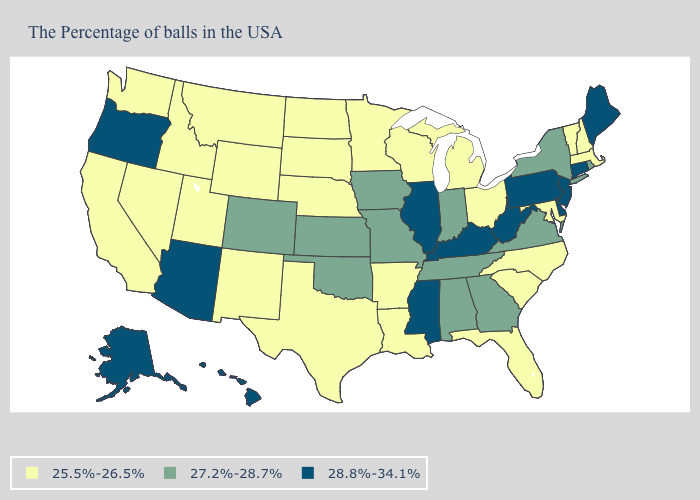What is the lowest value in the USA?
Be succinct. 25.5%-26.5%. Among the states that border South Dakota , does Nebraska have the highest value?
Answer briefly. No. Which states hav the highest value in the MidWest?
Quick response, please. Illinois. Which states have the highest value in the USA?
Keep it brief. Maine, Connecticut, New Jersey, Delaware, Pennsylvania, West Virginia, Kentucky, Illinois, Mississippi, Arizona, Oregon, Alaska, Hawaii. Is the legend a continuous bar?
Write a very short answer. No. What is the lowest value in the USA?
Write a very short answer. 25.5%-26.5%. Which states have the lowest value in the MidWest?
Concise answer only. Ohio, Michigan, Wisconsin, Minnesota, Nebraska, South Dakota, North Dakota. What is the lowest value in states that border Missouri?
Answer briefly. 25.5%-26.5%. Name the states that have a value in the range 28.8%-34.1%?
Concise answer only. Maine, Connecticut, New Jersey, Delaware, Pennsylvania, West Virginia, Kentucky, Illinois, Mississippi, Arizona, Oregon, Alaska, Hawaii. Name the states that have a value in the range 28.8%-34.1%?
Keep it brief. Maine, Connecticut, New Jersey, Delaware, Pennsylvania, West Virginia, Kentucky, Illinois, Mississippi, Arizona, Oregon, Alaska, Hawaii. Which states have the lowest value in the USA?
Keep it brief. Massachusetts, New Hampshire, Vermont, Maryland, North Carolina, South Carolina, Ohio, Florida, Michigan, Wisconsin, Louisiana, Arkansas, Minnesota, Nebraska, Texas, South Dakota, North Dakota, Wyoming, New Mexico, Utah, Montana, Idaho, Nevada, California, Washington. What is the value of Colorado?
Concise answer only. 27.2%-28.7%. What is the highest value in states that border Indiana?
Be succinct. 28.8%-34.1%. Name the states that have a value in the range 28.8%-34.1%?
Answer briefly. Maine, Connecticut, New Jersey, Delaware, Pennsylvania, West Virginia, Kentucky, Illinois, Mississippi, Arizona, Oregon, Alaska, Hawaii. What is the highest value in the USA?
Give a very brief answer. 28.8%-34.1%. 